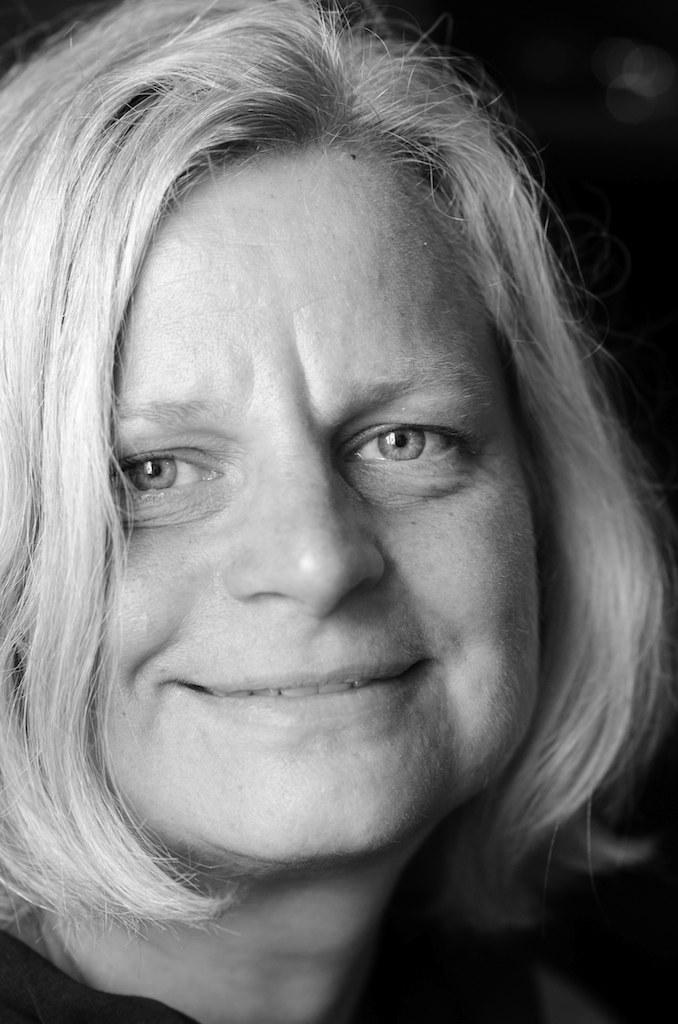What is the main subject of the image? There is a face of a person in the image. What type of oatmeal is being served in the hall where the tramp is performing? There is no mention of oatmeal, a hall, or a tramp in the image. The image only features the face of a person. 